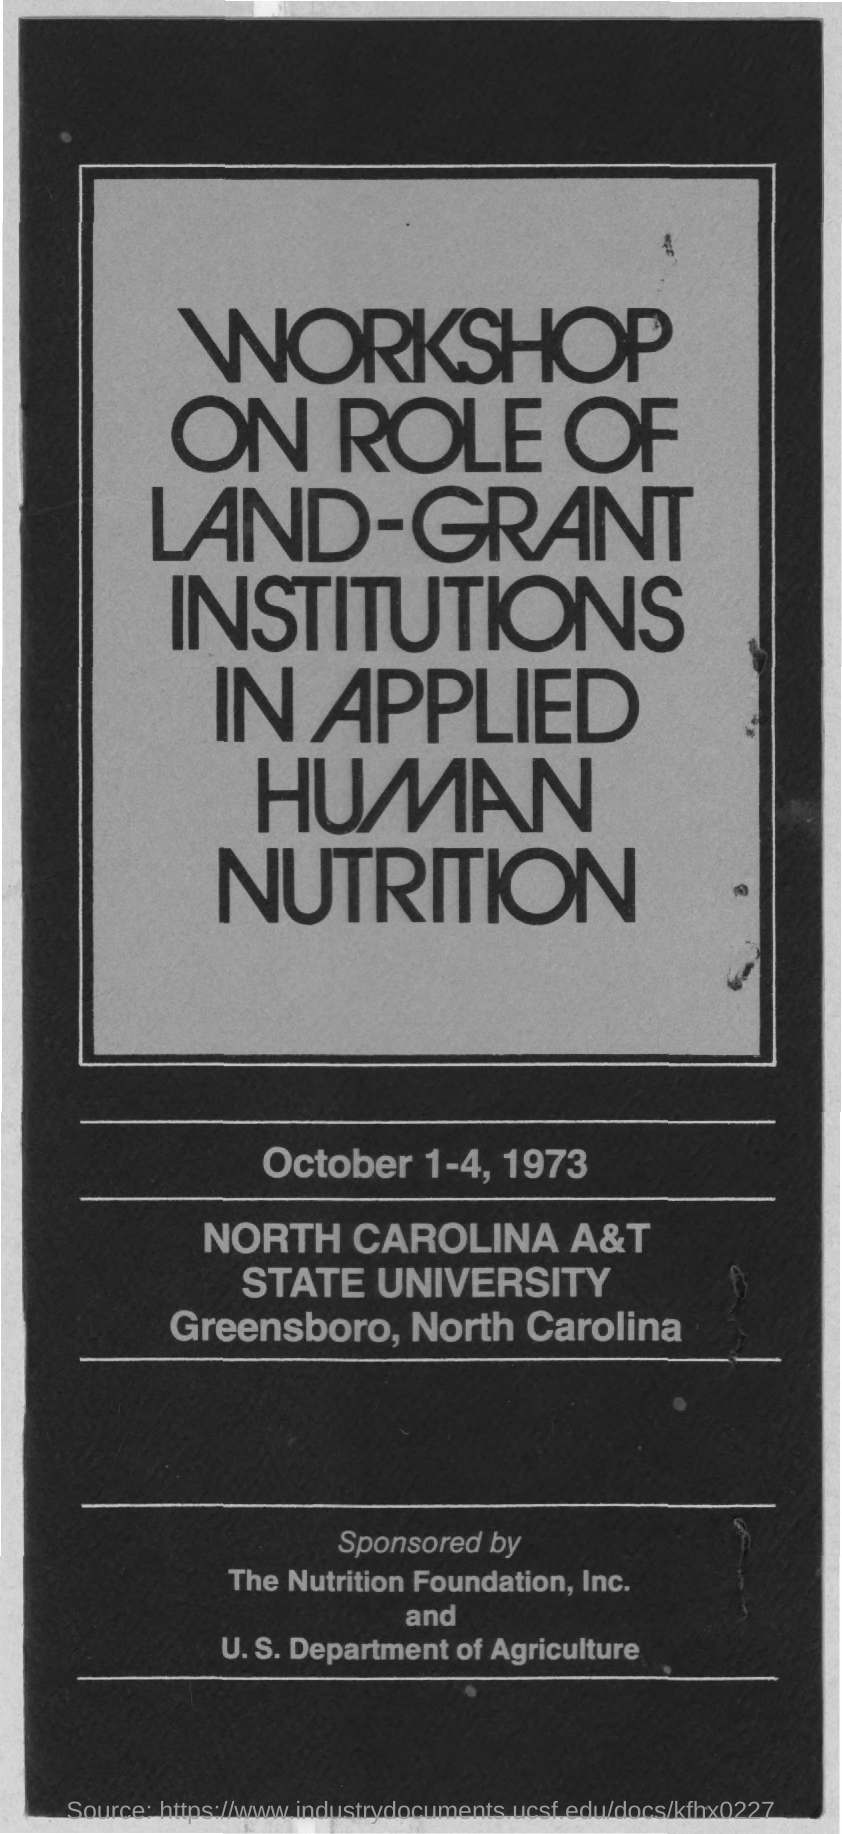Specify some key components in this picture. This workshop was conducted on the dates of October 1-4, 1973. 